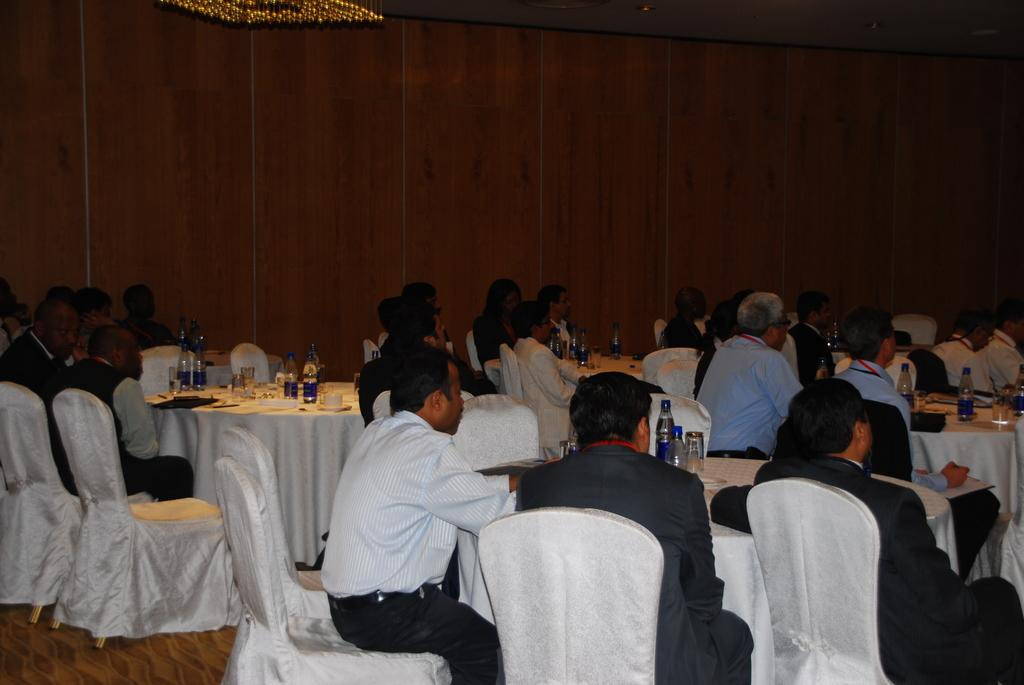How many persons are sitting in the room? There are many persons sitting on chairs in the room. What type of furniture is present in the room? There are many chairs and tables in the room. What items can be found on the tables? There are bottles, glasses, cups, and saucers on the tables. What is visible in the background of the image? There is a wall in the background. How many horses are visible in the image? There are no horses present in the image. Can you see a bee buzzing around the tables in the image? There is no bee visible in the image. 